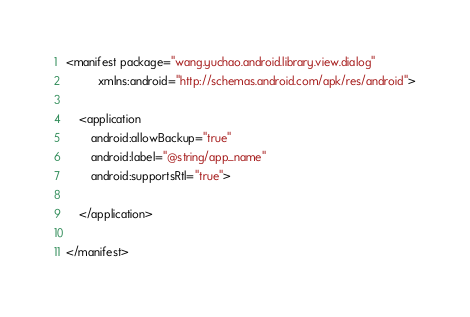<code> <loc_0><loc_0><loc_500><loc_500><_XML_><manifest package="wang.yuchao.android.library.view.dialog"
          xmlns:android="http://schemas.android.com/apk/res/android">

    <application
        android:allowBackup="true"
        android:label="@string/app_name"
        android:supportsRtl="true">

    </application>

</manifest>
</code> 